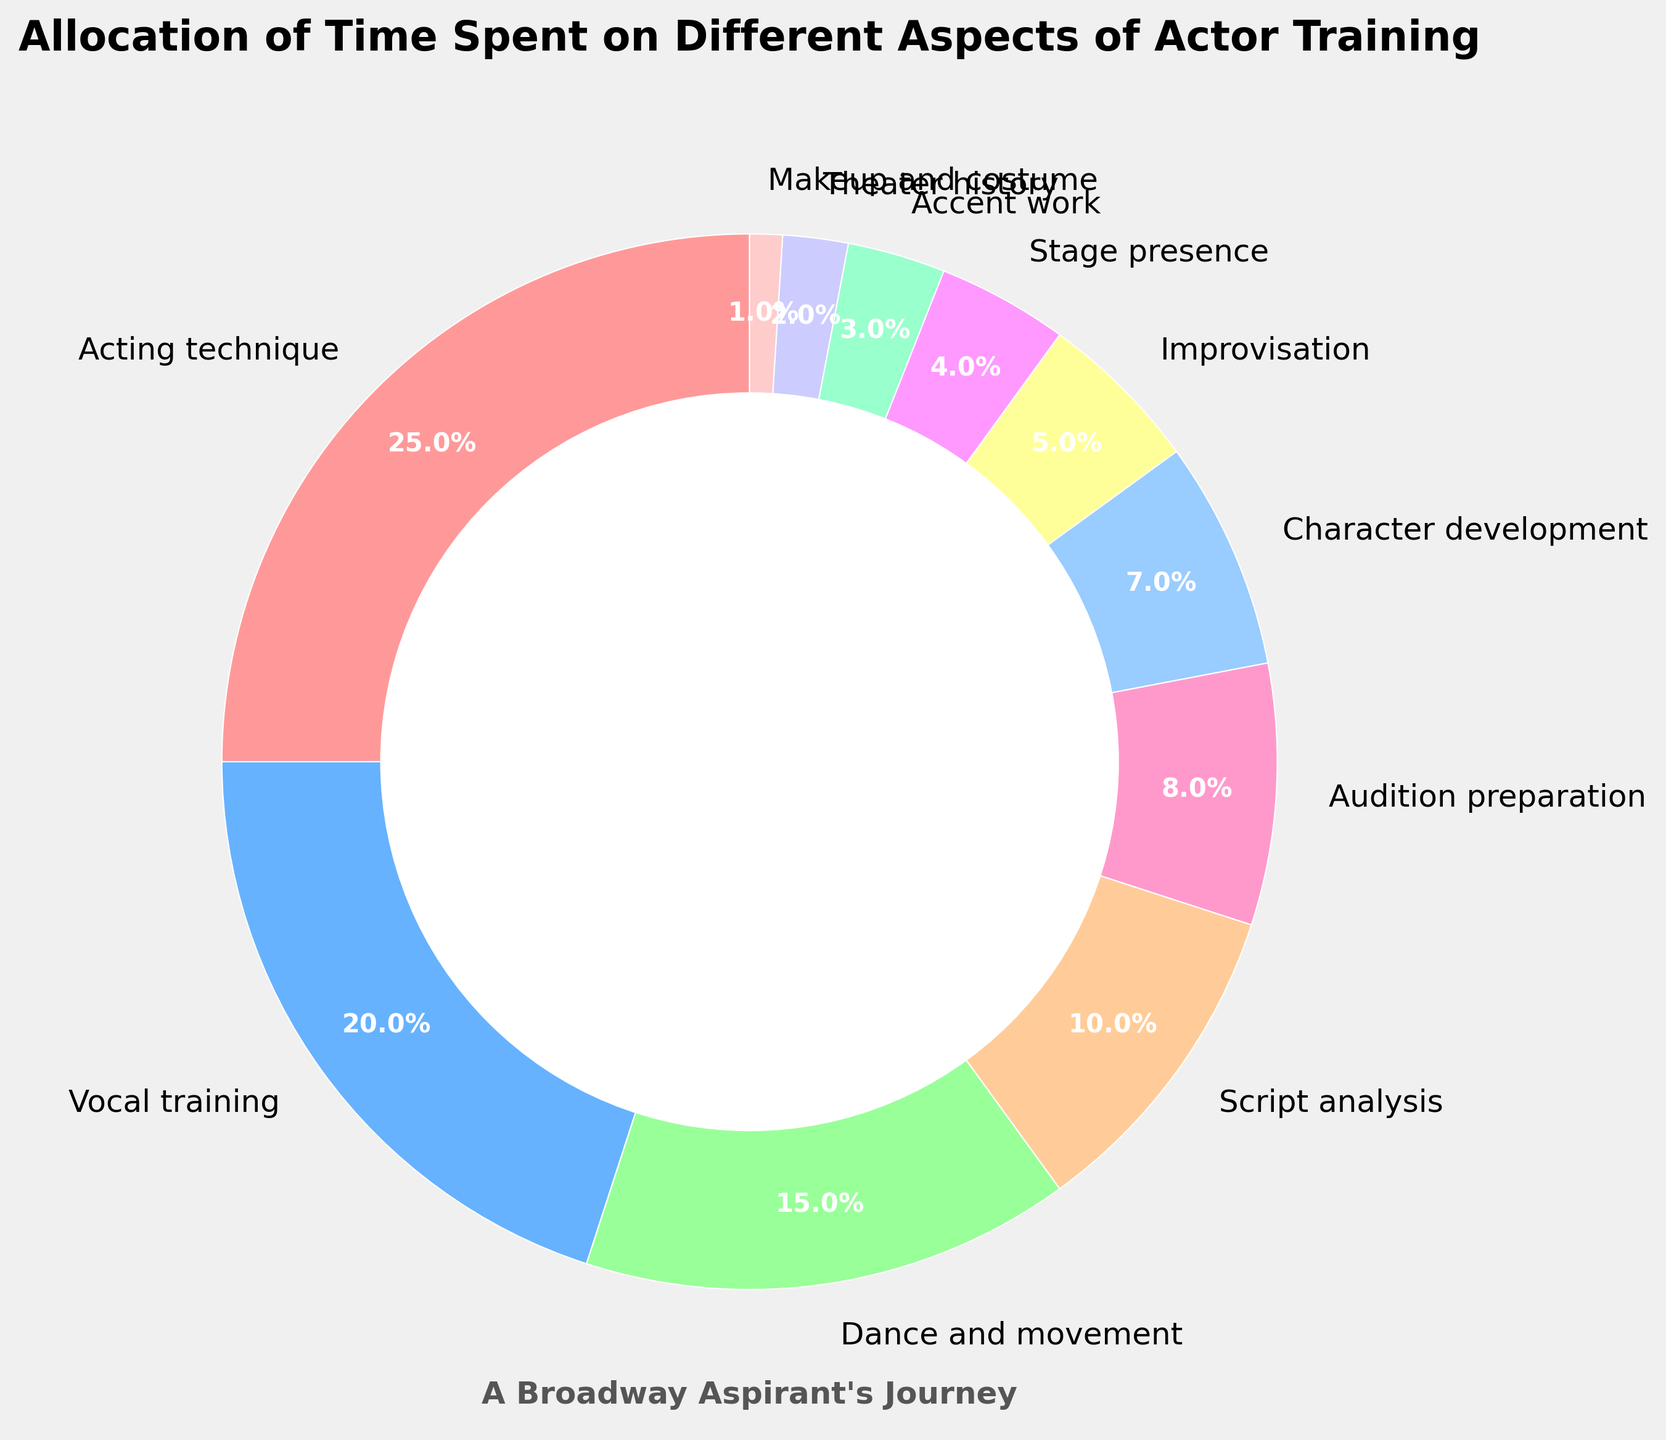What's the largest slice in the pie chart? The largest slice in the pie chart is the one with the highest percentage. From the data, "Acting technique" is 25%, which is greater than any other category.
Answer: Acting technique Which aspect of training has the smallest allocation of time? The smallest allocation of time in the pie chart is the one with the lowest percentage. From the data, "Makeup and costume" is 1%, which is the smallest.
Answer: Makeup and costume How much more time is allocated to Vocal training compared to Audition preparation? Vocal training is allocated 20% and Audition preparation is allocated 8%. The difference is 20% - 8% = 12%.
Answer: 12% What is the combined percentage of time spent on Dance and movement, and Improv? Dance and movement is 15% and Improvisation is 5%. Combined, it is 15% + 5% = 20%.
Answer: 20% Which slices use colors from the blue color spectrum? The colors in the pie chart allow us to identify the aspects within each shade. From the data provided, the slices assigned with blue spectrum colors are "Vocal training" and "Stage presence".
Answer: Vocal training and Stage presence How does the allocation of time for Character development compare to Script analysis and Accent work combined? Character development is allocated 7%. Script analysis and Accent work combined is 10% + 3% = 13%. Therefore, Character development is less than the combined allocation of Script analysis and Accent work.
Answer: Less What visual element emphasizes the title of the pie chart? The title is emphasized by being bold and having a larger font size compared to other text elements in the chart. Additionally, it is centrally placed above the pie chart.
Answer: Bold and larger font size, central placement 